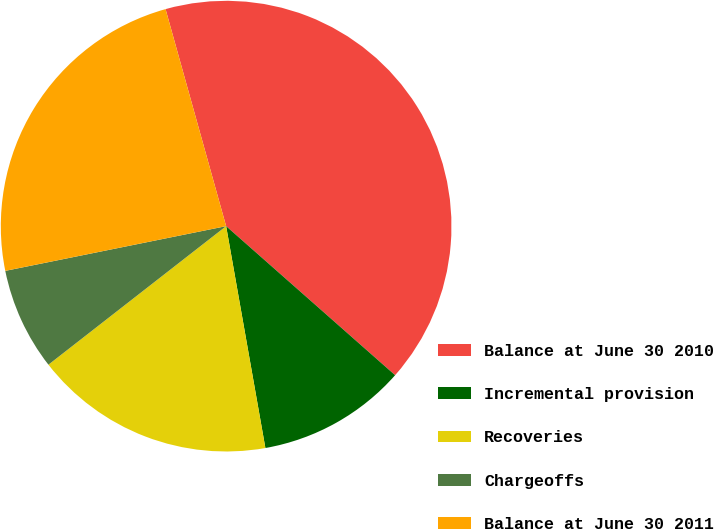Convert chart to OTSL. <chart><loc_0><loc_0><loc_500><loc_500><pie_chart><fcel>Balance at June 30 2010<fcel>Incremental provision<fcel>Recoveries<fcel>Chargeoffs<fcel>Balance at June 30 2011<nl><fcel>40.84%<fcel>10.71%<fcel>17.25%<fcel>7.36%<fcel>23.85%<nl></chart> 